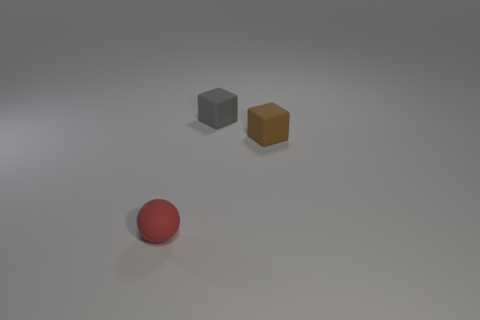How big is the brown cube? The brown cube appears to be medium-sized in comparison with the other objects present, it is larger than the red sphere but smaller than the grey cube. 